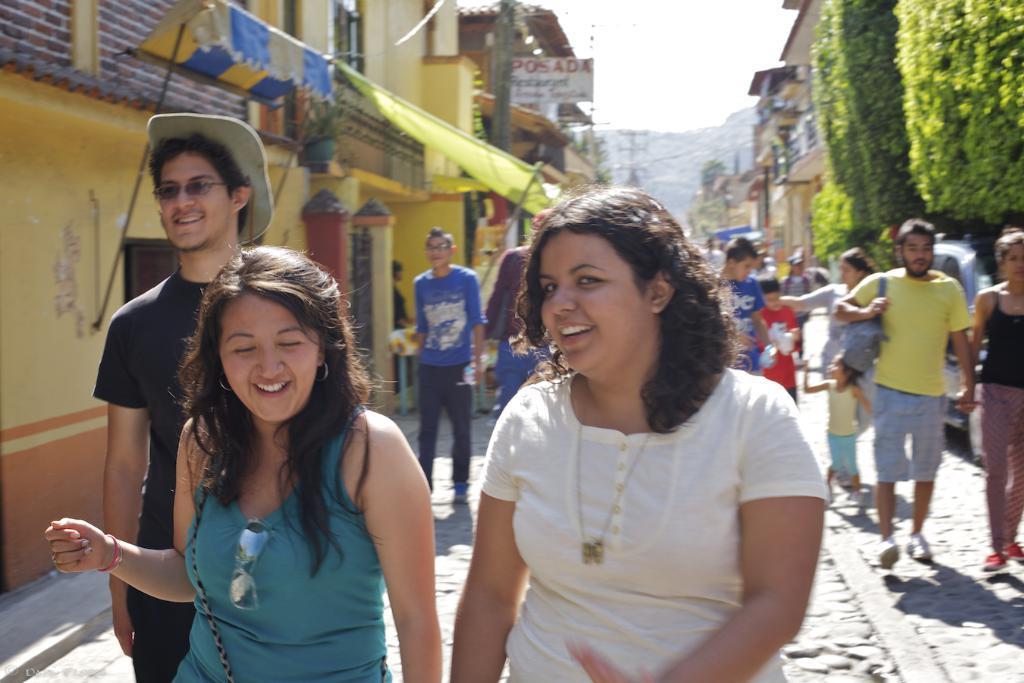Could you give a brief overview of what you see in this image? In this image we can see people walking. In the background there are buildings, hills and sky. On the right we can see trees. 